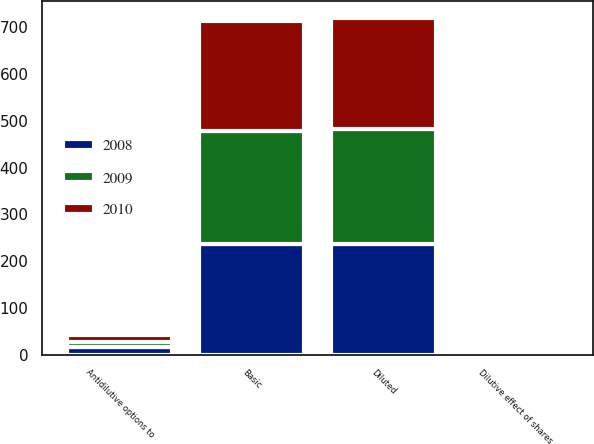Convert chart to OTSL. <chart><loc_0><loc_0><loc_500><loc_500><stacked_bar_chart><ecel><fcel>Basic<fcel>Dilutive effect of shares<fcel>Diluted<fcel>Antidilutive options to<nl><fcel>2010<fcel>235<fcel>1.6<fcel>236.6<fcel>15.5<nl><fcel>2008<fcel>236.1<fcel>1.7<fcel>237.8<fcel>15.6<nl><fcel>2009<fcel>242.4<fcel>2.9<fcel>245.3<fcel>11.3<nl></chart> 